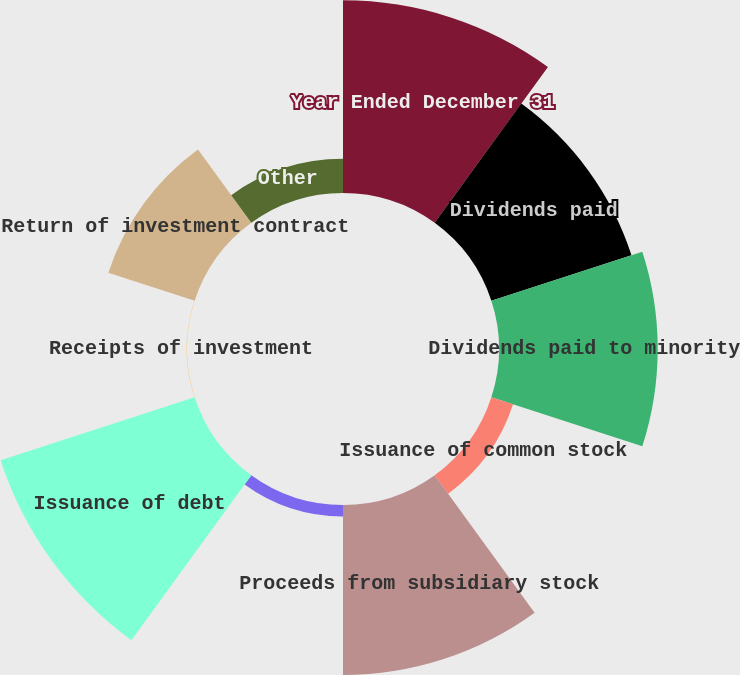Convert chart to OTSL. <chart><loc_0><loc_0><loc_500><loc_500><pie_chart><fcel>Year Ended December 31<fcel>Dividends paid<fcel>Dividends paid to minority<fcel>Issuance of common stock<fcel>Proceeds from subsidiary stock<fcel>Principal payments on debt<fcel>Issuance of debt<fcel>Receipts of investment<fcel>Return of investment contract<fcel>Other<nl><fcel>18.67%<fcel>14.28%<fcel>15.38%<fcel>2.21%<fcel>16.47%<fcel>1.11%<fcel>19.77%<fcel>0.02%<fcel>8.79%<fcel>3.31%<nl></chart> 